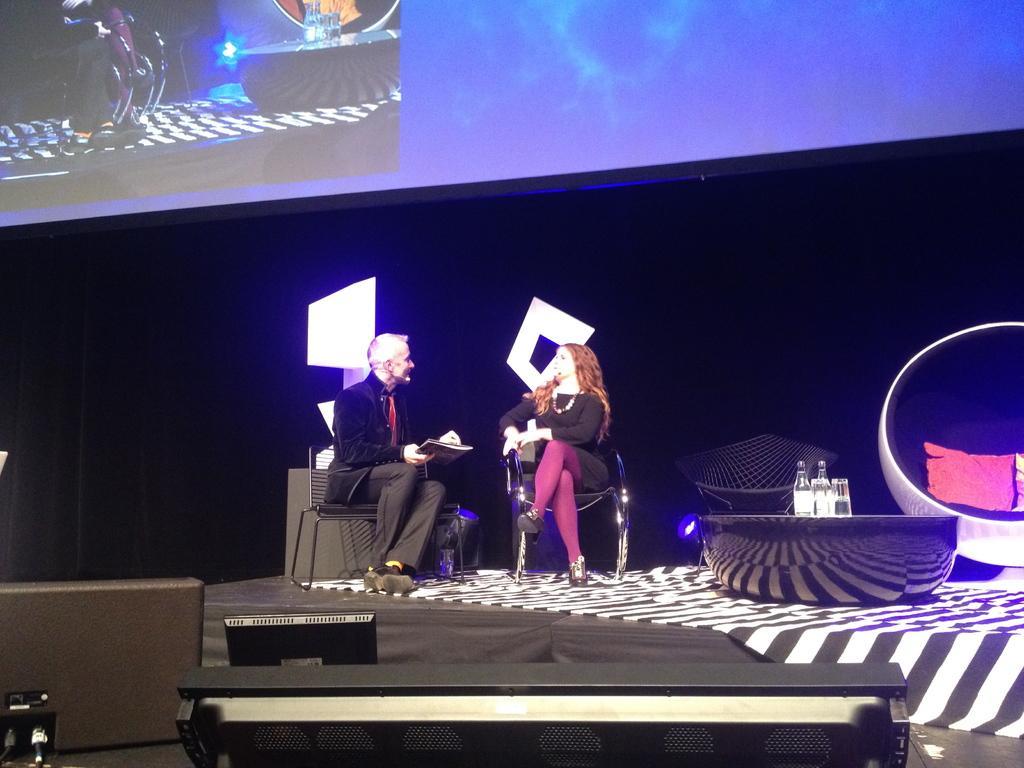In one or two sentences, can you explain what this image depicts? There are people sitting on the stage in the foreground area of the image, there is a screen at the top side, there are some objects at the bottom side. 